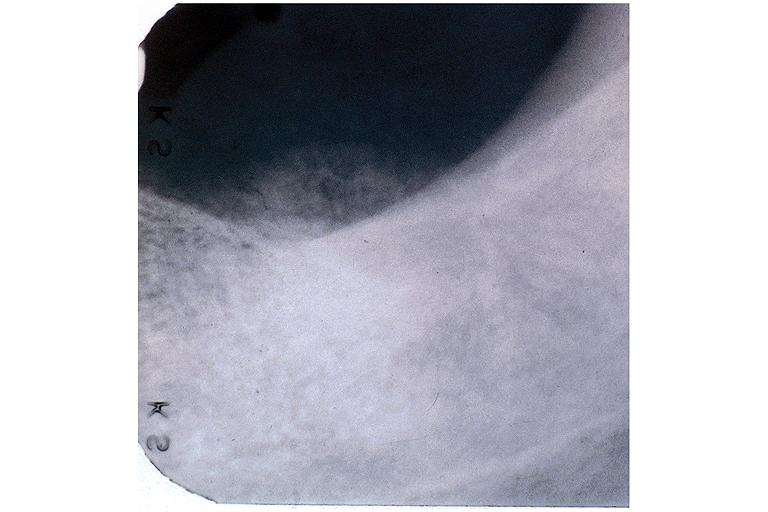does this image show osteosarcoma?
Answer the question using a single word or phrase. Yes 